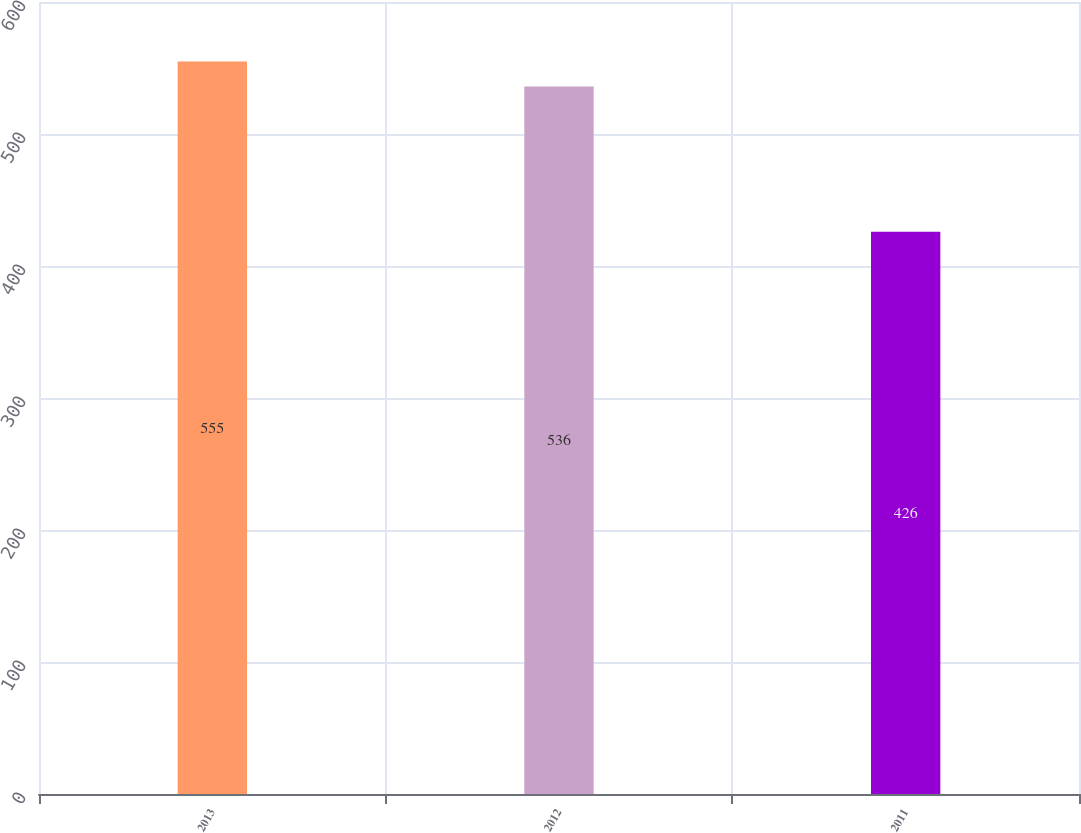Convert chart to OTSL. <chart><loc_0><loc_0><loc_500><loc_500><bar_chart><fcel>2013<fcel>2012<fcel>2011<nl><fcel>555<fcel>536<fcel>426<nl></chart> 